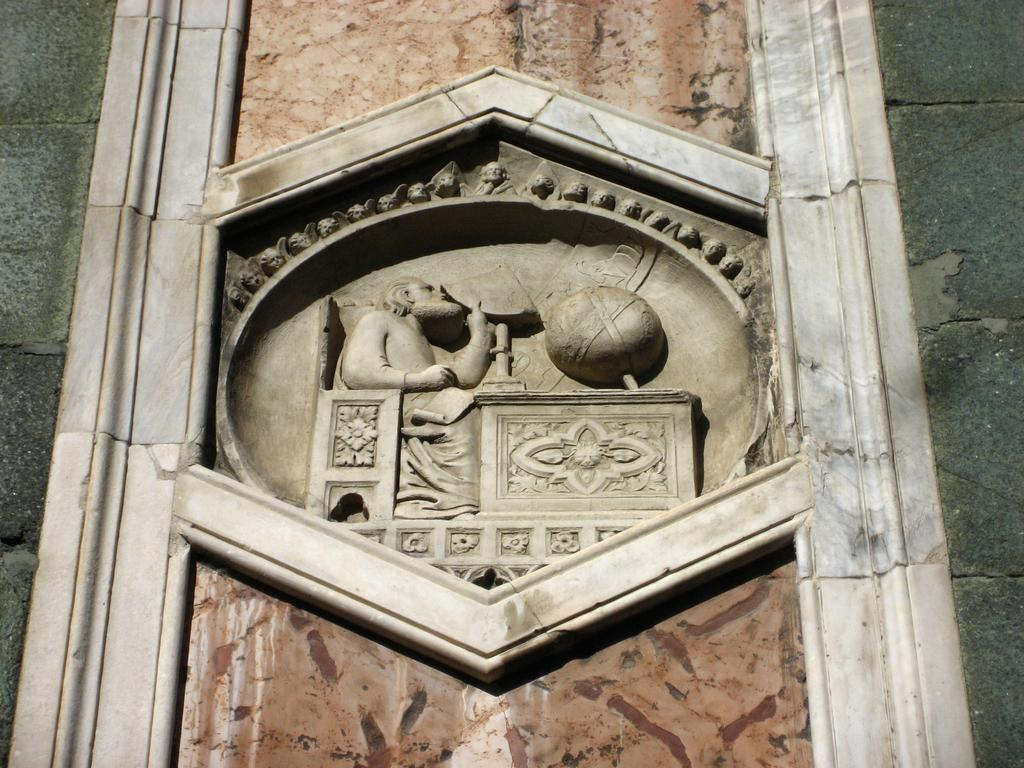What can be seen on the wall in the image? There is carving on the wall in the image. What is the color of the wall? The wall is in grey color. Can you hear the person laughing in the image? There is no person or laughter present in the image; it only features a wall with carving and its grey color. 